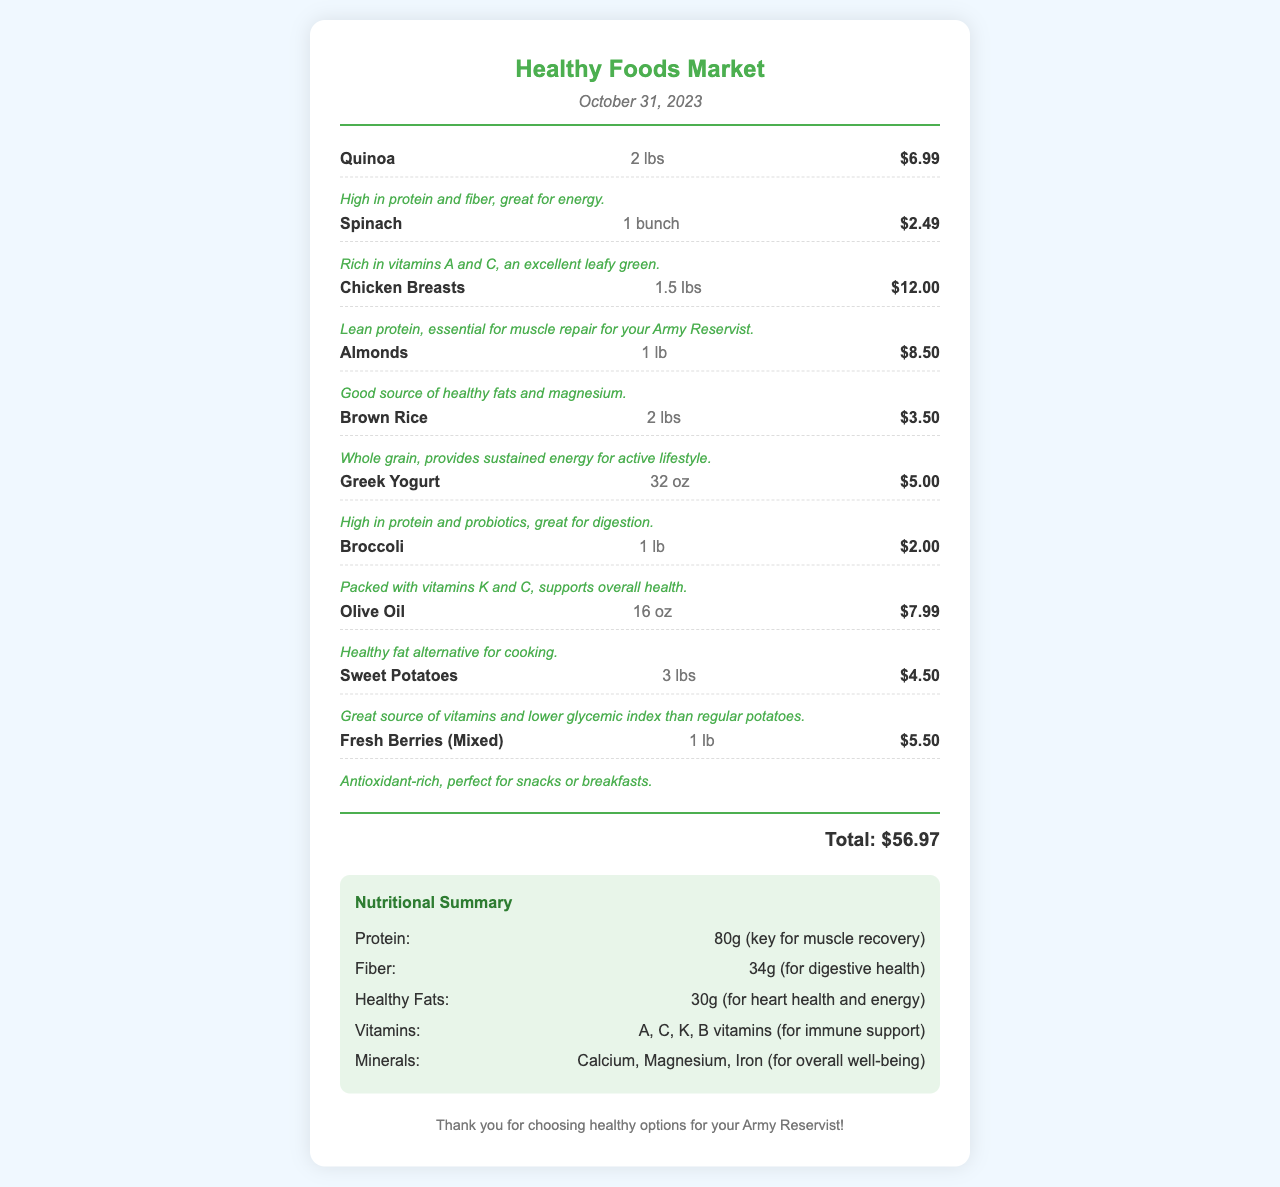What is the date of the receipt? The date of the receipt is provided at the top of the document.
Answer: October 31, 2023 How much did the almonds cost? The cost of the almonds is indicated along with their description in the items section.
Answer: $8.50 What is the total amount of the receipt? The total amount is calculated from all the individual item prices listed in the receipt.
Answer: $56.97 Which item is noted as rich in vitamins A and C? The document provides notes on each item, including health benefits.
Answer: Spinach What healthy fat alternative is listed on the receipt? The specific item representing a healthy fat alternative is mentioned among the items.
Answer: Olive Oil How many grams of protein are listed in the nutritional summary? The nutritional summary details the amount of protein from all items combined.
Answer: 80g What type of food is identified as a good source of healthy fats? The specific item is noted within the context of the food categories represented in the receipt.
Answer: Almonds Which item is mentioned specifically for muscle repair? The document highlights the benefits of chicken breasts for muscle recovery.
Answer: Chicken Breasts What are the items categorized under the healthier food choices? The items listed showcase healthier options for proper nutrition depicted in the receipt.
Answer: Quinoa, Spinach, Chicken Breasts, Almonds, Brown Rice, Greek Yogurt, Broccoli, Olive Oil, Sweet Potatoes, Fresh Berries 